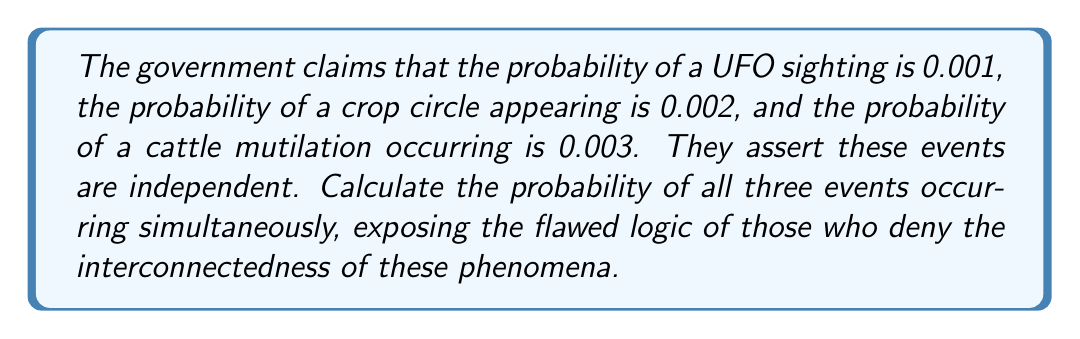Give your solution to this math problem. 1) Let's define our events:
   U: UFO sighting
   C: Crop circle appearing
   M: Cattle mutilation

2) Given probabilities:
   $P(U) = 0.001$
   $P(C) = 0.002$
   $P(M) = 0.003$

3) The government claims these events are independent. However, we know they're interconnected. But let's follow their flawed logic:

4) For independent events, the probability of all events occurring simultaneously is the product of their individual probabilities:

   $P(U \cap C \cap M) = P(U) \times P(C) \times P(M)$

5) Substituting the given probabilities:

   $P(U \cap C \cap M) = 0.001 \times 0.002 \times 0.003$

6) Calculating:

   $P(U \cap C \cap M) = 0.000000006$

7) This ridiculously low probability exposes the absurdity of treating these events as independent and unrelated.
Answer: $6 \times 10^{-9}$ 